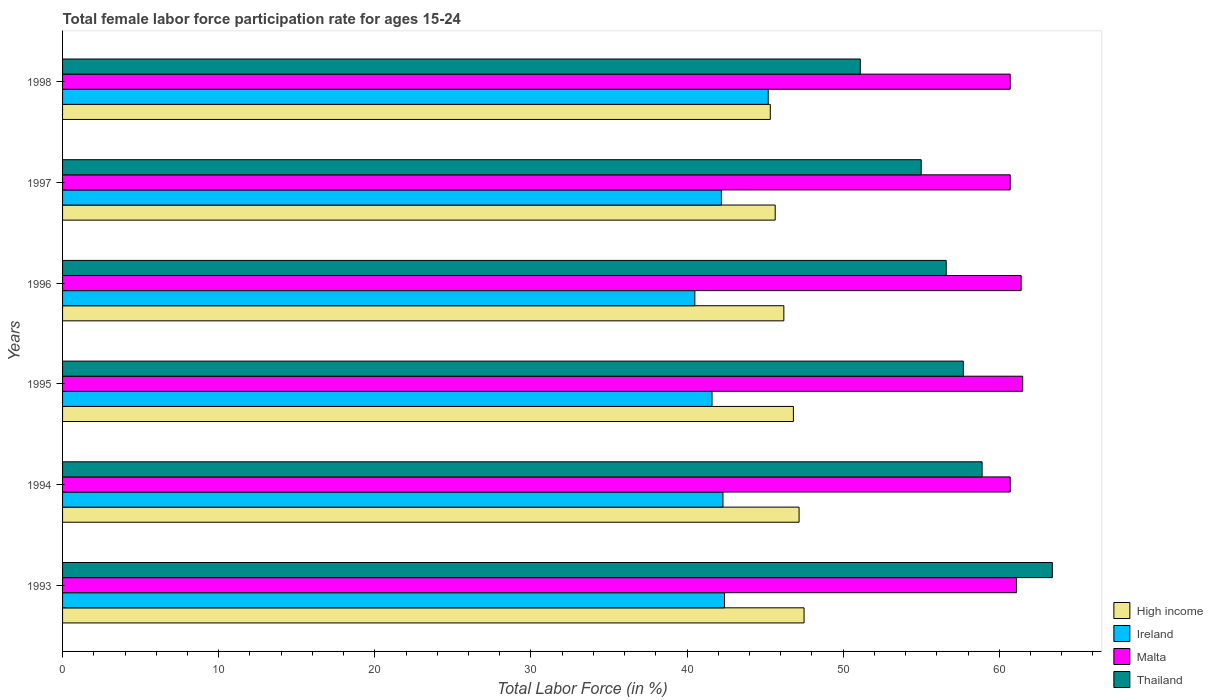How many groups of bars are there?
Ensure brevity in your answer.  6. Are the number of bars per tick equal to the number of legend labels?
Provide a succinct answer. Yes. How many bars are there on the 3rd tick from the top?
Your response must be concise. 4. How many bars are there on the 3rd tick from the bottom?
Ensure brevity in your answer.  4. What is the label of the 5th group of bars from the top?
Offer a terse response. 1994. In how many cases, is the number of bars for a given year not equal to the number of legend labels?
Keep it short and to the point. 0. What is the female labor force participation rate in Malta in 1997?
Offer a terse response. 60.7. Across all years, what is the maximum female labor force participation rate in High income?
Your answer should be compact. 47.5. Across all years, what is the minimum female labor force participation rate in High income?
Your response must be concise. 45.33. What is the total female labor force participation rate in High income in the graph?
Offer a terse response. 278.66. What is the difference between the female labor force participation rate in Malta in 1996 and that in 1997?
Ensure brevity in your answer.  0.7. What is the difference between the female labor force participation rate in Malta in 1996 and the female labor force participation rate in High income in 1995?
Provide a short and direct response. 14.59. What is the average female labor force participation rate in Ireland per year?
Provide a succinct answer. 42.37. In the year 1995, what is the difference between the female labor force participation rate in Malta and female labor force participation rate in High income?
Your answer should be compact. 14.69. What is the ratio of the female labor force participation rate in Ireland in 1993 to that in 1998?
Your answer should be very brief. 0.94. Is the difference between the female labor force participation rate in Malta in 1994 and 1997 greater than the difference between the female labor force participation rate in High income in 1994 and 1997?
Your answer should be compact. No. What is the difference between the highest and the second highest female labor force participation rate in Ireland?
Keep it short and to the point. 2.8. What is the difference between the highest and the lowest female labor force participation rate in Thailand?
Give a very brief answer. 12.3. Is the sum of the female labor force participation rate in High income in 1993 and 1994 greater than the maximum female labor force participation rate in Thailand across all years?
Your answer should be very brief. Yes. Is it the case that in every year, the sum of the female labor force participation rate in Malta and female labor force participation rate in Ireland is greater than the sum of female labor force participation rate in Thailand and female labor force participation rate in High income?
Your answer should be compact. Yes. What does the 3rd bar from the top in 1994 represents?
Offer a terse response. Ireland. What does the 2nd bar from the bottom in 1995 represents?
Keep it short and to the point. Ireland. Is it the case that in every year, the sum of the female labor force participation rate in Ireland and female labor force participation rate in Malta is greater than the female labor force participation rate in Thailand?
Provide a succinct answer. Yes. Are the values on the major ticks of X-axis written in scientific E-notation?
Provide a succinct answer. No. Does the graph contain grids?
Ensure brevity in your answer.  No. Where does the legend appear in the graph?
Offer a very short reply. Bottom right. How many legend labels are there?
Offer a very short reply. 4. How are the legend labels stacked?
Offer a terse response. Vertical. What is the title of the graph?
Offer a very short reply. Total female labor force participation rate for ages 15-24. Does "Latin America(all income levels)" appear as one of the legend labels in the graph?
Your response must be concise. No. What is the label or title of the Y-axis?
Keep it short and to the point. Years. What is the Total Labor Force (in %) of High income in 1993?
Make the answer very short. 47.5. What is the Total Labor Force (in %) of Ireland in 1993?
Make the answer very short. 42.4. What is the Total Labor Force (in %) of Malta in 1993?
Make the answer very short. 61.1. What is the Total Labor Force (in %) of Thailand in 1993?
Your answer should be very brief. 63.4. What is the Total Labor Force (in %) of High income in 1994?
Your answer should be very brief. 47.18. What is the Total Labor Force (in %) in Ireland in 1994?
Provide a short and direct response. 42.3. What is the Total Labor Force (in %) in Malta in 1994?
Your response must be concise. 60.7. What is the Total Labor Force (in %) of Thailand in 1994?
Your response must be concise. 58.9. What is the Total Labor Force (in %) of High income in 1995?
Make the answer very short. 46.81. What is the Total Labor Force (in %) of Ireland in 1995?
Your response must be concise. 41.6. What is the Total Labor Force (in %) of Malta in 1995?
Offer a very short reply. 61.5. What is the Total Labor Force (in %) of Thailand in 1995?
Your answer should be compact. 57.7. What is the Total Labor Force (in %) in High income in 1996?
Your response must be concise. 46.2. What is the Total Labor Force (in %) of Ireland in 1996?
Keep it short and to the point. 40.5. What is the Total Labor Force (in %) in Malta in 1996?
Make the answer very short. 61.4. What is the Total Labor Force (in %) in Thailand in 1996?
Offer a very short reply. 56.6. What is the Total Labor Force (in %) of High income in 1997?
Give a very brief answer. 45.65. What is the Total Labor Force (in %) in Ireland in 1997?
Offer a terse response. 42.2. What is the Total Labor Force (in %) in Malta in 1997?
Ensure brevity in your answer.  60.7. What is the Total Labor Force (in %) in Thailand in 1997?
Offer a very short reply. 55. What is the Total Labor Force (in %) of High income in 1998?
Your response must be concise. 45.33. What is the Total Labor Force (in %) in Ireland in 1998?
Your answer should be compact. 45.2. What is the Total Labor Force (in %) of Malta in 1998?
Provide a succinct answer. 60.7. What is the Total Labor Force (in %) of Thailand in 1998?
Give a very brief answer. 51.1. Across all years, what is the maximum Total Labor Force (in %) of High income?
Give a very brief answer. 47.5. Across all years, what is the maximum Total Labor Force (in %) in Ireland?
Your response must be concise. 45.2. Across all years, what is the maximum Total Labor Force (in %) of Malta?
Keep it short and to the point. 61.5. Across all years, what is the maximum Total Labor Force (in %) in Thailand?
Keep it short and to the point. 63.4. Across all years, what is the minimum Total Labor Force (in %) of High income?
Keep it short and to the point. 45.33. Across all years, what is the minimum Total Labor Force (in %) in Ireland?
Provide a short and direct response. 40.5. Across all years, what is the minimum Total Labor Force (in %) of Malta?
Your response must be concise. 60.7. Across all years, what is the minimum Total Labor Force (in %) of Thailand?
Your response must be concise. 51.1. What is the total Total Labor Force (in %) of High income in the graph?
Offer a terse response. 278.66. What is the total Total Labor Force (in %) in Ireland in the graph?
Your answer should be compact. 254.2. What is the total Total Labor Force (in %) in Malta in the graph?
Provide a succinct answer. 366.1. What is the total Total Labor Force (in %) in Thailand in the graph?
Keep it short and to the point. 342.7. What is the difference between the Total Labor Force (in %) in High income in 1993 and that in 1994?
Ensure brevity in your answer.  0.32. What is the difference between the Total Labor Force (in %) of High income in 1993 and that in 1995?
Give a very brief answer. 0.68. What is the difference between the Total Labor Force (in %) in Ireland in 1993 and that in 1995?
Provide a succinct answer. 0.8. What is the difference between the Total Labor Force (in %) of Malta in 1993 and that in 1995?
Keep it short and to the point. -0.4. What is the difference between the Total Labor Force (in %) in High income in 1993 and that in 1996?
Offer a terse response. 1.29. What is the difference between the Total Labor Force (in %) in Thailand in 1993 and that in 1996?
Offer a terse response. 6.8. What is the difference between the Total Labor Force (in %) of High income in 1993 and that in 1997?
Your answer should be compact. 1.85. What is the difference between the Total Labor Force (in %) of High income in 1993 and that in 1998?
Make the answer very short. 2.16. What is the difference between the Total Labor Force (in %) of Ireland in 1993 and that in 1998?
Offer a terse response. -2.8. What is the difference between the Total Labor Force (in %) of Thailand in 1993 and that in 1998?
Give a very brief answer. 12.3. What is the difference between the Total Labor Force (in %) in High income in 1994 and that in 1995?
Give a very brief answer. 0.36. What is the difference between the Total Labor Force (in %) of High income in 1994 and that in 1996?
Make the answer very short. 0.98. What is the difference between the Total Labor Force (in %) of Ireland in 1994 and that in 1996?
Your response must be concise. 1.8. What is the difference between the Total Labor Force (in %) of Malta in 1994 and that in 1996?
Give a very brief answer. -0.7. What is the difference between the Total Labor Force (in %) of Thailand in 1994 and that in 1996?
Keep it short and to the point. 2.3. What is the difference between the Total Labor Force (in %) of High income in 1994 and that in 1997?
Keep it short and to the point. 1.53. What is the difference between the Total Labor Force (in %) in Ireland in 1994 and that in 1997?
Your answer should be very brief. 0.1. What is the difference between the Total Labor Force (in %) in High income in 1994 and that in 1998?
Offer a very short reply. 1.84. What is the difference between the Total Labor Force (in %) of Ireland in 1994 and that in 1998?
Your answer should be very brief. -2.9. What is the difference between the Total Labor Force (in %) of Malta in 1994 and that in 1998?
Keep it short and to the point. 0. What is the difference between the Total Labor Force (in %) in Thailand in 1994 and that in 1998?
Keep it short and to the point. 7.8. What is the difference between the Total Labor Force (in %) of High income in 1995 and that in 1996?
Make the answer very short. 0.61. What is the difference between the Total Labor Force (in %) of Ireland in 1995 and that in 1996?
Your response must be concise. 1.1. What is the difference between the Total Labor Force (in %) in Thailand in 1995 and that in 1996?
Give a very brief answer. 1.1. What is the difference between the Total Labor Force (in %) of High income in 1995 and that in 1997?
Your answer should be very brief. 1.17. What is the difference between the Total Labor Force (in %) of Ireland in 1995 and that in 1997?
Ensure brevity in your answer.  -0.6. What is the difference between the Total Labor Force (in %) of Malta in 1995 and that in 1997?
Your response must be concise. 0.8. What is the difference between the Total Labor Force (in %) of Thailand in 1995 and that in 1997?
Keep it short and to the point. 2.7. What is the difference between the Total Labor Force (in %) in High income in 1995 and that in 1998?
Provide a short and direct response. 1.48. What is the difference between the Total Labor Force (in %) of High income in 1996 and that in 1997?
Your answer should be compact. 0.55. What is the difference between the Total Labor Force (in %) in Malta in 1996 and that in 1997?
Your answer should be very brief. 0.7. What is the difference between the Total Labor Force (in %) in Thailand in 1996 and that in 1997?
Give a very brief answer. 1.6. What is the difference between the Total Labor Force (in %) of High income in 1996 and that in 1998?
Your answer should be very brief. 0.87. What is the difference between the Total Labor Force (in %) in High income in 1997 and that in 1998?
Your response must be concise. 0.31. What is the difference between the Total Labor Force (in %) in Ireland in 1997 and that in 1998?
Provide a short and direct response. -3. What is the difference between the Total Labor Force (in %) in High income in 1993 and the Total Labor Force (in %) in Ireland in 1994?
Your response must be concise. 5.2. What is the difference between the Total Labor Force (in %) of High income in 1993 and the Total Labor Force (in %) of Malta in 1994?
Offer a very short reply. -13.2. What is the difference between the Total Labor Force (in %) of High income in 1993 and the Total Labor Force (in %) of Thailand in 1994?
Your answer should be compact. -11.4. What is the difference between the Total Labor Force (in %) of Ireland in 1993 and the Total Labor Force (in %) of Malta in 1994?
Your answer should be very brief. -18.3. What is the difference between the Total Labor Force (in %) of Ireland in 1993 and the Total Labor Force (in %) of Thailand in 1994?
Make the answer very short. -16.5. What is the difference between the Total Labor Force (in %) in High income in 1993 and the Total Labor Force (in %) in Ireland in 1995?
Your answer should be very brief. 5.9. What is the difference between the Total Labor Force (in %) in High income in 1993 and the Total Labor Force (in %) in Malta in 1995?
Give a very brief answer. -14. What is the difference between the Total Labor Force (in %) in High income in 1993 and the Total Labor Force (in %) in Thailand in 1995?
Your response must be concise. -10.2. What is the difference between the Total Labor Force (in %) of Ireland in 1993 and the Total Labor Force (in %) of Malta in 1995?
Provide a short and direct response. -19.1. What is the difference between the Total Labor Force (in %) in Ireland in 1993 and the Total Labor Force (in %) in Thailand in 1995?
Keep it short and to the point. -15.3. What is the difference between the Total Labor Force (in %) in Malta in 1993 and the Total Labor Force (in %) in Thailand in 1995?
Your response must be concise. 3.4. What is the difference between the Total Labor Force (in %) in High income in 1993 and the Total Labor Force (in %) in Ireland in 1996?
Keep it short and to the point. 7. What is the difference between the Total Labor Force (in %) of High income in 1993 and the Total Labor Force (in %) of Malta in 1996?
Your answer should be very brief. -13.9. What is the difference between the Total Labor Force (in %) in High income in 1993 and the Total Labor Force (in %) in Thailand in 1996?
Your response must be concise. -9.1. What is the difference between the Total Labor Force (in %) in Ireland in 1993 and the Total Labor Force (in %) in Malta in 1996?
Your answer should be compact. -19. What is the difference between the Total Labor Force (in %) in Ireland in 1993 and the Total Labor Force (in %) in Thailand in 1996?
Make the answer very short. -14.2. What is the difference between the Total Labor Force (in %) of Malta in 1993 and the Total Labor Force (in %) of Thailand in 1996?
Offer a very short reply. 4.5. What is the difference between the Total Labor Force (in %) in High income in 1993 and the Total Labor Force (in %) in Ireland in 1997?
Give a very brief answer. 5.3. What is the difference between the Total Labor Force (in %) in High income in 1993 and the Total Labor Force (in %) in Malta in 1997?
Your answer should be very brief. -13.2. What is the difference between the Total Labor Force (in %) in High income in 1993 and the Total Labor Force (in %) in Thailand in 1997?
Offer a terse response. -7.5. What is the difference between the Total Labor Force (in %) in Ireland in 1993 and the Total Labor Force (in %) in Malta in 1997?
Your response must be concise. -18.3. What is the difference between the Total Labor Force (in %) in Ireland in 1993 and the Total Labor Force (in %) in Thailand in 1997?
Ensure brevity in your answer.  -12.6. What is the difference between the Total Labor Force (in %) in High income in 1993 and the Total Labor Force (in %) in Ireland in 1998?
Offer a terse response. 2.3. What is the difference between the Total Labor Force (in %) in High income in 1993 and the Total Labor Force (in %) in Malta in 1998?
Make the answer very short. -13.2. What is the difference between the Total Labor Force (in %) of High income in 1993 and the Total Labor Force (in %) of Thailand in 1998?
Keep it short and to the point. -3.6. What is the difference between the Total Labor Force (in %) in Ireland in 1993 and the Total Labor Force (in %) in Malta in 1998?
Ensure brevity in your answer.  -18.3. What is the difference between the Total Labor Force (in %) in Malta in 1993 and the Total Labor Force (in %) in Thailand in 1998?
Make the answer very short. 10. What is the difference between the Total Labor Force (in %) in High income in 1994 and the Total Labor Force (in %) in Ireland in 1995?
Your answer should be very brief. 5.58. What is the difference between the Total Labor Force (in %) in High income in 1994 and the Total Labor Force (in %) in Malta in 1995?
Ensure brevity in your answer.  -14.32. What is the difference between the Total Labor Force (in %) in High income in 1994 and the Total Labor Force (in %) in Thailand in 1995?
Your answer should be very brief. -10.52. What is the difference between the Total Labor Force (in %) in Ireland in 1994 and the Total Labor Force (in %) in Malta in 1995?
Provide a succinct answer. -19.2. What is the difference between the Total Labor Force (in %) in Ireland in 1994 and the Total Labor Force (in %) in Thailand in 1995?
Keep it short and to the point. -15.4. What is the difference between the Total Labor Force (in %) of Malta in 1994 and the Total Labor Force (in %) of Thailand in 1995?
Keep it short and to the point. 3. What is the difference between the Total Labor Force (in %) in High income in 1994 and the Total Labor Force (in %) in Ireland in 1996?
Keep it short and to the point. 6.68. What is the difference between the Total Labor Force (in %) of High income in 1994 and the Total Labor Force (in %) of Malta in 1996?
Offer a terse response. -14.22. What is the difference between the Total Labor Force (in %) of High income in 1994 and the Total Labor Force (in %) of Thailand in 1996?
Offer a very short reply. -9.42. What is the difference between the Total Labor Force (in %) of Ireland in 1994 and the Total Labor Force (in %) of Malta in 1996?
Make the answer very short. -19.1. What is the difference between the Total Labor Force (in %) of Ireland in 1994 and the Total Labor Force (in %) of Thailand in 1996?
Keep it short and to the point. -14.3. What is the difference between the Total Labor Force (in %) in Malta in 1994 and the Total Labor Force (in %) in Thailand in 1996?
Your answer should be compact. 4.1. What is the difference between the Total Labor Force (in %) in High income in 1994 and the Total Labor Force (in %) in Ireland in 1997?
Offer a very short reply. 4.98. What is the difference between the Total Labor Force (in %) in High income in 1994 and the Total Labor Force (in %) in Malta in 1997?
Offer a very short reply. -13.52. What is the difference between the Total Labor Force (in %) of High income in 1994 and the Total Labor Force (in %) of Thailand in 1997?
Provide a short and direct response. -7.82. What is the difference between the Total Labor Force (in %) in Ireland in 1994 and the Total Labor Force (in %) in Malta in 1997?
Offer a terse response. -18.4. What is the difference between the Total Labor Force (in %) in Ireland in 1994 and the Total Labor Force (in %) in Thailand in 1997?
Give a very brief answer. -12.7. What is the difference between the Total Labor Force (in %) in High income in 1994 and the Total Labor Force (in %) in Ireland in 1998?
Your answer should be very brief. 1.98. What is the difference between the Total Labor Force (in %) in High income in 1994 and the Total Labor Force (in %) in Malta in 1998?
Offer a terse response. -13.52. What is the difference between the Total Labor Force (in %) of High income in 1994 and the Total Labor Force (in %) of Thailand in 1998?
Give a very brief answer. -3.92. What is the difference between the Total Labor Force (in %) in Ireland in 1994 and the Total Labor Force (in %) in Malta in 1998?
Offer a terse response. -18.4. What is the difference between the Total Labor Force (in %) in High income in 1995 and the Total Labor Force (in %) in Ireland in 1996?
Your answer should be compact. 6.31. What is the difference between the Total Labor Force (in %) in High income in 1995 and the Total Labor Force (in %) in Malta in 1996?
Ensure brevity in your answer.  -14.59. What is the difference between the Total Labor Force (in %) in High income in 1995 and the Total Labor Force (in %) in Thailand in 1996?
Your answer should be compact. -9.79. What is the difference between the Total Labor Force (in %) in Ireland in 1995 and the Total Labor Force (in %) in Malta in 1996?
Provide a short and direct response. -19.8. What is the difference between the Total Labor Force (in %) in Malta in 1995 and the Total Labor Force (in %) in Thailand in 1996?
Keep it short and to the point. 4.9. What is the difference between the Total Labor Force (in %) of High income in 1995 and the Total Labor Force (in %) of Ireland in 1997?
Keep it short and to the point. 4.61. What is the difference between the Total Labor Force (in %) in High income in 1995 and the Total Labor Force (in %) in Malta in 1997?
Offer a very short reply. -13.89. What is the difference between the Total Labor Force (in %) of High income in 1995 and the Total Labor Force (in %) of Thailand in 1997?
Keep it short and to the point. -8.19. What is the difference between the Total Labor Force (in %) of Ireland in 1995 and the Total Labor Force (in %) of Malta in 1997?
Offer a very short reply. -19.1. What is the difference between the Total Labor Force (in %) of Ireland in 1995 and the Total Labor Force (in %) of Thailand in 1997?
Your answer should be compact. -13.4. What is the difference between the Total Labor Force (in %) in Malta in 1995 and the Total Labor Force (in %) in Thailand in 1997?
Provide a short and direct response. 6.5. What is the difference between the Total Labor Force (in %) in High income in 1995 and the Total Labor Force (in %) in Ireland in 1998?
Offer a very short reply. 1.61. What is the difference between the Total Labor Force (in %) of High income in 1995 and the Total Labor Force (in %) of Malta in 1998?
Your answer should be compact. -13.89. What is the difference between the Total Labor Force (in %) of High income in 1995 and the Total Labor Force (in %) of Thailand in 1998?
Offer a terse response. -4.29. What is the difference between the Total Labor Force (in %) of Ireland in 1995 and the Total Labor Force (in %) of Malta in 1998?
Your response must be concise. -19.1. What is the difference between the Total Labor Force (in %) in Ireland in 1995 and the Total Labor Force (in %) in Thailand in 1998?
Make the answer very short. -9.5. What is the difference between the Total Labor Force (in %) in Malta in 1995 and the Total Labor Force (in %) in Thailand in 1998?
Your response must be concise. 10.4. What is the difference between the Total Labor Force (in %) of High income in 1996 and the Total Labor Force (in %) of Ireland in 1997?
Keep it short and to the point. 4. What is the difference between the Total Labor Force (in %) in High income in 1996 and the Total Labor Force (in %) in Malta in 1997?
Keep it short and to the point. -14.5. What is the difference between the Total Labor Force (in %) of High income in 1996 and the Total Labor Force (in %) of Thailand in 1997?
Make the answer very short. -8.8. What is the difference between the Total Labor Force (in %) in Ireland in 1996 and the Total Labor Force (in %) in Malta in 1997?
Offer a very short reply. -20.2. What is the difference between the Total Labor Force (in %) of Ireland in 1996 and the Total Labor Force (in %) of Thailand in 1997?
Offer a terse response. -14.5. What is the difference between the Total Labor Force (in %) of Malta in 1996 and the Total Labor Force (in %) of Thailand in 1997?
Offer a terse response. 6.4. What is the difference between the Total Labor Force (in %) in High income in 1996 and the Total Labor Force (in %) in Malta in 1998?
Your response must be concise. -14.5. What is the difference between the Total Labor Force (in %) of High income in 1996 and the Total Labor Force (in %) of Thailand in 1998?
Provide a succinct answer. -4.9. What is the difference between the Total Labor Force (in %) of Ireland in 1996 and the Total Labor Force (in %) of Malta in 1998?
Give a very brief answer. -20.2. What is the difference between the Total Labor Force (in %) of Ireland in 1996 and the Total Labor Force (in %) of Thailand in 1998?
Offer a very short reply. -10.6. What is the difference between the Total Labor Force (in %) in Malta in 1996 and the Total Labor Force (in %) in Thailand in 1998?
Provide a succinct answer. 10.3. What is the difference between the Total Labor Force (in %) in High income in 1997 and the Total Labor Force (in %) in Ireland in 1998?
Keep it short and to the point. 0.45. What is the difference between the Total Labor Force (in %) of High income in 1997 and the Total Labor Force (in %) of Malta in 1998?
Provide a short and direct response. -15.05. What is the difference between the Total Labor Force (in %) of High income in 1997 and the Total Labor Force (in %) of Thailand in 1998?
Your answer should be compact. -5.45. What is the difference between the Total Labor Force (in %) in Ireland in 1997 and the Total Labor Force (in %) in Malta in 1998?
Your answer should be very brief. -18.5. What is the difference between the Total Labor Force (in %) of Ireland in 1997 and the Total Labor Force (in %) of Thailand in 1998?
Keep it short and to the point. -8.9. What is the difference between the Total Labor Force (in %) of Malta in 1997 and the Total Labor Force (in %) of Thailand in 1998?
Provide a short and direct response. 9.6. What is the average Total Labor Force (in %) in High income per year?
Ensure brevity in your answer.  46.44. What is the average Total Labor Force (in %) of Ireland per year?
Your response must be concise. 42.37. What is the average Total Labor Force (in %) of Malta per year?
Provide a short and direct response. 61.02. What is the average Total Labor Force (in %) in Thailand per year?
Keep it short and to the point. 57.12. In the year 1993, what is the difference between the Total Labor Force (in %) in High income and Total Labor Force (in %) in Ireland?
Offer a very short reply. 5.1. In the year 1993, what is the difference between the Total Labor Force (in %) in High income and Total Labor Force (in %) in Malta?
Your response must be concise. -13.6. In the year 1993, what is the difference between the Total Labor Force (in %) in High income and Total Labor Force (in %) in Thailand?
Give a very brief answer. -15.9. In the year 1993, what is the difference between the Total Labor Force (in %) of Ireland and Total Labor Force (in %) of Malta?
Your answer should be compact. -18.7. In the year 1993, what is the difference between the Total Labor Force (in %) in Ireland and Total Labor Force (in %) in Thailand?
Provide a short and direct response. -21. In the year 1993, what is the difference between the Total Labor Force (in %) of Malta and Total Labor Force (in %) of Thailand?
Provide a succinct answer. -2.3. In the year 1994, what is the difference between the Total Labor Force (in %) in High income and Total Labor Force (in %) in Ireland?
Keep it short and to the point. 4.88. In the year 1994, what is the difference between the Total Labor Force (in %) in High income and Total Labor Force (in %) in Malta?
Your response must be concise. -13.52. In the year 1994, what is the difference between the Total Labor Force (in %) in High income and Total Labor Force (in %) in Thailand?
Offer a very short reply. -11.72. In the year 1994, what is the difference between the Total Labor Force (in %) of Ireland and Total Labor Force (in %) of Malta?
Offer a very short reply. -18.4. In the year 1994, what is the difference between the Total Labor Force (in %) of Ireland and Total Labor Force (in %) of Thailand?
Your response must be concise. -16.6. In the year 1994, what is the difference between the Total Labor Force (in %) of Malta and Total Labor Force (in %) of Thailand?
Your answer should be very brief. 1.8. In the year 1995, what is the difference between the Total Labor Force (in %) of High income and Total Labor Force (in %) of Ireland?
Offer a terse response. 5.21. In the year 1995, what is the difference between the Total Labor Force (in %) of High income and Total Labor Force (in %) of Malta?
Your response must be concise. -14.69. In the year 1995, what is the difference between the Total Labor Force (in %) in High income and Total Labor Force (in %) in Thailand?
Make the answer very short. -10.89. In the year 1995, what is the difference between the Total Labor Force (in %) in Ireland and Total Labor Force (in %) in Malta?
Give a very brief answer. -19.9. In the year 1995, what is the difference between the Total Labor Force (in %) of Ireland and Total Labor Force (in %) of Thailand?
Give a very brief answer. -16.1. In the year 1996, what is the difference between the Total Labor Force (in %) in High income and Total Labor Force (in %) in Ireland?
Make the answer very short. 5.7. In the year 1996, what is the difference between the Total Labor Force (in %) in High income and Total Labor Force (in %) in Malta?
Your answer should be compact. -15.2. In the year 1996, what is the difference between the Total Labor Force (in %) in High income and Total Labor Force (in %) in Thailand?
Keep it short and to the point. -10.4. In the year 1996, what is the difference between the Total Labor Force (in %) of Ireland and Total Labor Force (in %) of Malta?
Your answer should be compact. -20.9. In the year 1996, what is the difference between the Total Labor Force (in %) in Ireland and Total Labor Force (in %) in Thailand?
Your answer should be compact. -16.1. In the year 1996, what is the difference between the Total Labor Force (in %) of Malta and Total Labor Force (in %) of Thailand?
Offer a terse response. 4.8. In the year 1997, what is the difference between the Total Labor Force (in %) of High income and Total Labor Force (in %) of Ireland?
Provide a short and direct response. 3.45. In the year 1997, what is the difference between the Total Labor Force (in %) in High income and Total Labor Force (in %) in Malta?
Ensure brevity in your answer.  -15.05. In the year 1997, what is the difference between the Total Labor Force (in %) of High income and Total Labor Force (in %) of Thailand?
Make the answer very short. -9.35. In the year 1997, what is the difference between the Total Labor Force (in %) of Ireland and Total Labor Force (in %) of Malta?
Make the answer very short. -18.5. In the year 1997, what is the difference between the Total Labor Force (in %) of Ireland and Total Labor Force (in %) of Thailand?
Ensure brevity in your answer.  -12.8. In the year 1997, what is the difference between the Total Labor Force (in %) in Malta and Total Labor Force (in %) in Thailand?
Provide a short and direct response. 5.7. In the year 1998, what is the difference between the Total Labor Force (in %) of High income and Total Labor Force (in %) of Ireland?
Provide a succinct answer. 0.13. In the year 1998, what is the difference between the Total Labor Force (in %) in High income and Total Labor Force (in %) in Malta?
Your answer should be compact. -15.37. In the year 1998, what is the difference between the Total Labor Force (in %) in High income and Total Labor Force (in %) in Thailand?
Provide a short and direct response. -5.77. In the year 1998, what is the difference between the Total Labor Force (in %) in Ireland and Total Labor Force (in %) in Malta?
Make the answer very short. -15.5. What is the ratio of the Total Labor Force (in %) of High income in 1993 to that in 1994?
Give a very brief answer. 1.01. What is the ratio of the Total Labor Force (in %) of Malta in 1993 to that in 1994?
Provide a succinct answer. 1.01. What is the ratio of the Total Labor Force (in %) of Thailand in 1993 to that in 1994?
Keep it short and to the point. 1.08. What is the ratio of the Total Labor Force (in %) in High income in 1993 to that in 1995?
Your answer should be very brief. 1.01. What is the ratio of the Total Labor Force (in %) in Ireland in 1993 to that in 1995?
Offer a very short reply. 1.02. What is the ratio of the Total Labor Force (in %) of Malta in 1993 to that in 1995?
Ensure brevity in your answer.  0.99. What is the ratio of the Total Labor Force (in %) of Thailand in 1993 to that in 1995?
Provide a short and direct response. 1.1. What is the ratio of the Total Labor Force (in %) in High income in 1993 to that in 1996?
Give a very brief answer. 1.03. What is the ratio of the Total Labor Force (in %) in Ireland in 1993 to that in 1996?
Keep it short and to the point. 1.05. What is the ratio of the Total Labor Force (in %) in Malta in 1993 to that in 1996?
Offer a terse response. 1. What is the ratio of the Total Labor Force (in %) of Thailand in 1993 to that in 1996?
Offer a terse response. 1.12. What is the ratio of the Total Labor Force (in %) of High income in 1993 to that in 1997?
Your answer should be compact. 1.04. What is the ratio of the Total Labor Force (in %) in Malta in 1993 to that in 1997?
Offer a very short reply. 1.01. What is the ratio of the Total Labor Force (in %) in Thailand in 1993 to that in 1997?
Your answer should be very brief. 1.15. What is the ratio of the Total Labor Force (in %) of High income in 1993 to that in 1998?
Offer a terse response. 1.05. What is the ratio of the Total Labor Force (in %) of Ireland in 1993 to that in 1998?
Your answer should be compact. 0.94. What is the ratio of the Total Labor Force (in %) of Malta in 1993 to that in 1998?
Give a very brief answer. 1.01. What is the ratio of the Total Labor Force (in %) in Thailand in 1993 to that in 1998?
Your answer should be compact. 1.24. What is the ratio of the Total Labor Force (in %) of Ireland in 1994 to that in 1995?
Your answer should be compact. 1.02. What is the ratio of the Total Labor Force (in %) in Thailand in 1994 to that in 1995?
Your answer should be very brief. 1.02. What is the ratio of the Total Labor Force (in %) of High income in 1994 to that in 1996?
Your response must be concise. 1.02. What is the ratio of the Total Labor Force (in %) in Ireland in 1994 to that in 1996?
Give a very brief answer. 1.04. What is the ratio of the Total Labor Force (in %) of Malta in 1994 to that in 1996?
Provide a succinct answer. 0.99. What is the ratio of the Total Labor Force (in %) in Thailand in 1994 to that in 1996?
Your answer should be very brief. 1.04. What is the ratio of the Total Labor Force (in %) of High income in 1994 to that in 1997?
Your response must be concise. 1.03. What is the ratio of the Total Labor Force (in %) in Malta in 1994 to that in 1997?
Keep it short and to the point. 1. What is the ratio of the Total Labor Force (in %) in Thailand in 1994 to that in 1997?
Offer a terse response. 1.07. What is the ratio of the Total Labor Force (in %) of High income in 1994 to that in 1998?
Your response must be concise. 1.04. What is the ratio of the Total Labor Force (in %) of Ireland in 1994 to that in 1998?
Your answer should be compact. 0.94. What is the ratio of the Total Labor Force (in %) in Thailand in 1994 to that in 1998?
Provide a succinct answer. 1.15. What is the ratio of the Total Labor Force (in %) of High income in 1995 to that in 1996?
Your response must be concise. 1.01. What is the ratio of the Total Labor Force (in %) in Ireland in 1995 to that in 1996?
Provide a succinct answer. 1.03. What is the ratio of the Total Labor Force (in %) in Malta in 1995 to that in 1996?
Provide a succinct answer. 1. What is the ratio of the Total Labor Force (in %) of Thailand in 1995 to that in 1996?
Your answer should be very brief. 1.02. What is the ratio of the Total Labor Force (in %) of High income in 1995 to that in 1997?
Offer a terse response. 1.03. What is the ratio of the Total Labor Force (in %) in Ireland in 1995 to that in 1997?
Keep it short and to the point. 0.99. What is the ratio of the Total Labor Force (in %) in Malta in 1995 to that in 1997?
Offer a very short reply. 1.01. What is the ratio of the Total Labor Force (in %) in Thailand in 1995 to that in 1997?
Keep it short and to the point. 1.05. What is the ratio of the Total Labor Force (in %) of High income in 1995 to that in 1998?
Provide a short and direct response. 1.03. What is the ratio of the Total Labor Force (in %) of Ireland in 1995 to that in 1998?
Provide a short and direct response. 0.92. What is the ratio of the Total Labor Force (in %) in Malta in 1995 to that in 1998?
Make the answer very short. 1.01. What is the ratio of the Total Labor Force (in %) in Thailand in 1995 to that in 1998?
Make the answer very short. 1.13. What is the ratio of the Total Labor Force (in %) of High income in 1996 to that in 1997?
Make the answer very short. 1.01. What is the ratio of the Total Labor Force (in %) of Ireland in 1996 to that in 1997?
Make the answer very short. 0.96. What is the ratio of the Total Labor Force (in %) of Malta in 1996 to that in 1997?
Your response must be concise. 1.01. What is the ratio of the Total Labor Force (in %) in Thailand in 1996 to that in 1997?
Give a very brief answer. 1.03. What is the ratio of the Total Labor Force (in %) in High income in 1996 to that in 1998?
Make the answer very short. 1.02. What is the ratio of the Total Labor Force (in %) of Ireland in 1996 to that in 1998?
Give a very brief answer. 0.9. What is the ratio of the Total Labor Force (in %) in Malta in 1996 to that in 1998?
Offer a terse response. 1.01. What is the ratio of the Total Labor Force (in %) of Thailand in 1996 to that in 1998?
Provide a short and direct response. 1.11. What is the ratio of the Total Labor Force (in %) in Ireland in 1997 to that in 1998?
Provide a short and direct response. 0.93. What is the ratio of the Total Labor Force (in %) of Malta in 1997 to that in 1998?
Make the answer very short. 1. What is the ratio of the Total Labor Force (in %) of Thailand in 1997 to that in 1998?
Make the answer very short. 1.08. What is the difference between the highest and the second highest Total Labor Force (in %) of High income?
Give a very brief answer. 0.32. What is the difference between the highest and the second highest Total Labor Force (in %) in Ireland?
Your answer should be very brief. 2.8. What is the difference between the highest and the second highest Total Labor Force (in %) in Malta?
Your answer should be compact. 0.1. What is the difference between the highest and the second highest Total Labor Force (in %) of Thailand?
Your answer should be very brief. 4.5. What is the difference between the highest and the lowest Total Labor Force (in %) of High income?
Offer a very short reply. 2.16. What is the difference between the highest and the lowest Total Labor Force (in %) of Thailand?
Ensure brevity in your answer.  12.3. 